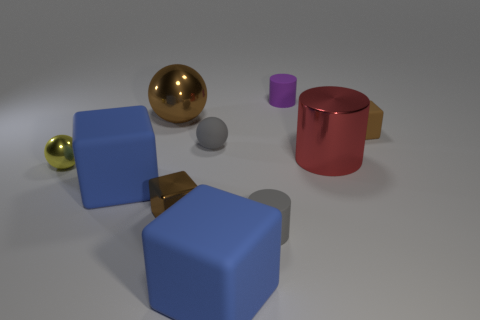Are there any large blue rubber blocks behind the brown metallic sphere?
Your response must be concise. No. Is there any other thing that is the same shape as the yellow metal object?
Ensure brevity in your answer.  Yes. Is the shape of the tiny yellow thing the same as the large brown thing?
Offer a terse response. Yes. Are there an equal number of big red objects that are to the left of the brown sphere and big blue rubber blocks that are on the right side of the tiny purple rubber thing?
Your answer should be very brief. Yes. How many other things are the same material as the large sphere?
Give a very brief answer. 3. What number of big things are blue rubber cubes or brown things?
Keep it short and to the point. 3. Is the number of balls on the right side of the tiny brown metal block the same as the number of tiny purple matte cylinders?
Provide a succinct answer. Yes. Is there a big red metallic cylinder to the right of the large brown thing that is behind the small metal ball?
Provide a short and direct response. Yes. How many other things are the same color as the rubber ball?
Ensure brevity in your answer.  1. What is the color of the matte ball?
Keep it short and to the point. Gray. 